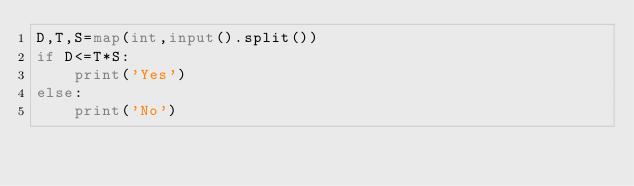Convert code to text. <code><loc_0><loc_0><loc_500><loc_500><_Python_>D,T,S=map(int,input().split())
if D<=T*S:
    print('Yes')
else:
    print('No')</code> 